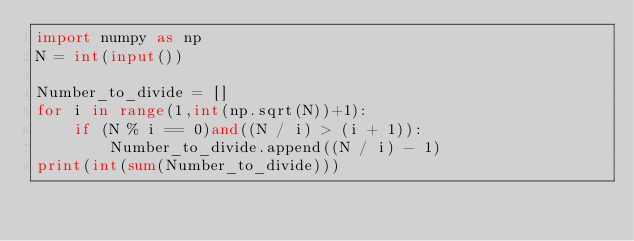Convert code to text. <code><loc_0><loc_0><loc_500><loc_500><_Python_>import numpy as np
N = int(input())

Number_to_divide = []
for i in range(1,int(np.sqrt(N))+1):
    if (N % i == 0)and((N / i) > (i + 1)):
        Number_to_divide.append((N / i) - 1)
print(int(sum(Number_to_divide)))

</code> 